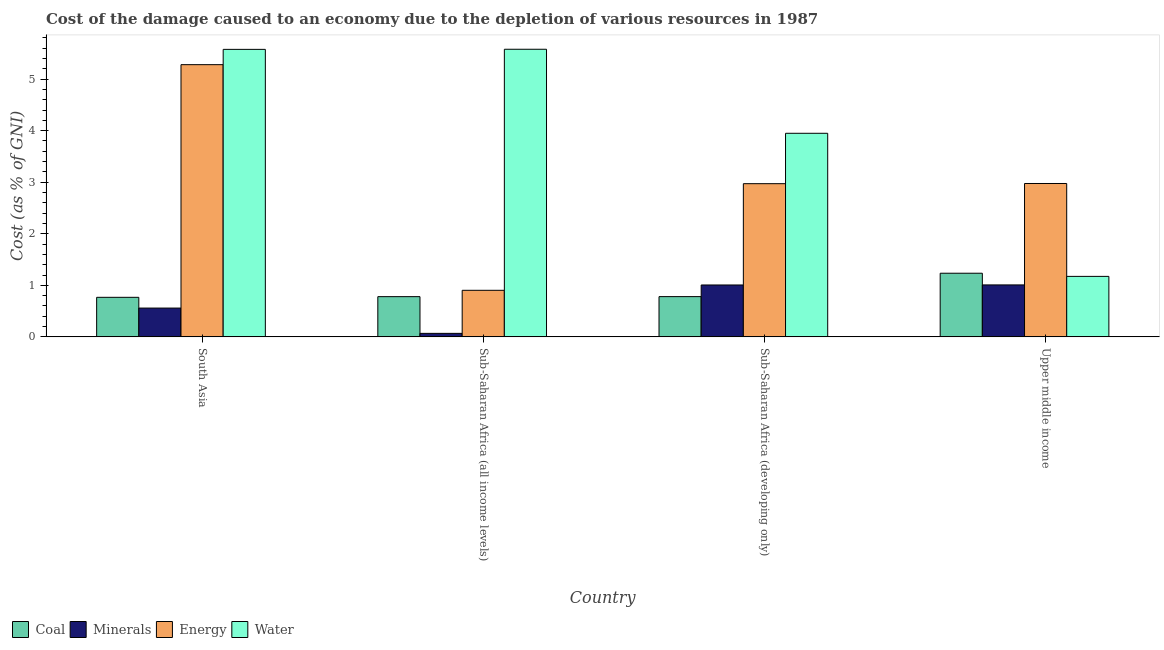How many different coloured bars are there?
Ensure brevity in your answer.  4. How many groups of bars are there?
Make the answer very short. 4. Are the number of bars on each tick of the X-axis equal?
Your answer should be very brief. Yes. What is the label of the 2nd group of bars from the left?
Provide a succinct answer. Sub-Saharan Africa (all income levels). What is the cost of damage due to depletion of minerals in Sub-Saharan Africa (developing only)?
Your response must be concise. 1.01. Across all countries, what is the maximum cost of damage due to depletion of coal?
Provide a short and direct response. 1.23. Across all countries, what is the minimum cost of damage due to depletion of energy?
Keep it short and to the point. 0.9. In which country was the cost of damage due to depletion of coal maximum?
Offer a very short reply. Upper middle income. In which country was the cost of damage due to depletion of minerals minimum?
Offer a very short reply. Sub-Saharan Africa (all income levels). What is the total cost of damage due to depletion of water in the graph?
Make the answer very short. 16.28. What is the difference between the cost of damage due to depletion of water in Sub-Saharan Africa (all income levels) and that in Upper middle income?
Your answer should be compact. 4.41. What is the difference between the cost of damage due to depletion of coal in Sub-Saharan Africa (all income levels) and the cost of damage due to depletion of energy in Sub-Saharan Africa (developing only)?
Ensure brevity in your answer.  -2.19. What is the average cost of damage due to depletion of minerals per country?
Provide a succinct answer. 0.66. What is the difference between the cost of damage due to depletion of minerals and cost of damage due to depletion of water in Sub-Saharan Africa (all income levels)?
Your response must be concise. -5.51. In how many countries, is the cost of damage due to depletion of minerals greater than 1 %?
Your answer should be compact. 2. What is the ratio of the cost of damage due to depletion of energy in South Asia to that in Upper middle income?
Ensure brevity in your answer.  1.77. Is the cost of damage due to depletion of energy in South Asia less than that in Sub-Saharan Africa (all income levels)?
Provide a short and direct response. No. Is the difference between the cost of damage due to depletion of minerals in Sub-Saharan Africa (developing only) and Upper middle income greater than the difference between the cost of damage due to depletion of energy in Sub-Saharan Africa (developing only) and Upper middle income?
Your answer should be very brief. Yes. What is the difference between the highest and the second highest cost of damage due to depletion of energy?
Ensure brevity in your answer.  2.31. What is the difference between the highest and the lowest cost of damage due to depletion of energy?
Give a very brief answer. 4.38. What does the 2nd bar from the left in Sub-Saharan Africa (developing only) represents?
Your answer should be compact. Minerals. What does the 4th bar from the right in Upper middle income represents?
Your answer should be compact. Coal. How many bars are there?
Keep it short and to the point. 16. How many countries are there in the graph?
Give a very brief answer. 4. What is the difference between two consecutive major ticks on the Y-axis?
Provide a short and direct response. 1. Are the values on the major ticks of Y-axis written in scientific E-notation?
Provide a short and direct response. No. Where does the legend appear in the graph?
Your response must be concise. Bottom left. How are the legend labels stacked?
Give a very brief answer. Horizontal. What is the title of the graph?
Provide a short and direct response. Cost of the damage caused to an economy due to the depletion of various resources in 1987 . Does "Permanent crop land" appear as one of the legend labels in the graph?
Provide a succinct answer. No. What is the label or title of the Y-axis?
Provide a succinct answer. Cost (as % of GNI). What is the Cost (as % of GNI) of Coal in South Asia?
Ensure brevity in your answer.  0.77. What is the Cost (as % of GNI) in Minerals in South Asia?
Give a very brief answer. 0.56. What is the Cost (as % of GNI) of Energy in South Asia?
Ensure brevity in your answer.  5.28. What is the Cost (as % of GNI) in Water in South Asia?
Provide a succinct answer. 5.58. What is the Cost (as % of GNI) in Coal in Sub-Saharan Africa (all income levels)?
Your answer should be compact. 0.78. What is the Cost (as % of GNI) of Minerals in Sub-Saharan Africa (all income levels)?
Your answer should be compact. 0.07. What is the Cost (as % of GNI) of Energy in Sub-Saharan Africa (all income levels)?
Your answer should be compact. 0.9. What is the Cost (as % of GNI) of Water in Sub-Saharan Africa (all income levels)?
Make the answer very short. 5.58. What is the Cost (as % of GNI) of Coal in Sub-Saharan Africa (developing only)?
Ensure brevity in your answer.  0.78. What is the Cost (as % of GNI) of Minerals in Sub-Saharan Africa (developing only)?
Provide a succinct answer. 1.01. What is the Cost (as % of GNI) of Energy in Sub-Saharan Africa (developing only)?
Provide a succinct answer. 2.97. What is the Cost (as % of GNI) in Water in Sub-Saharan Africa (developing only)?
Your answer should be very brief. 3.95. What is the Cost (as % of GNI) in Coal in Upper middle income?
Keep it short and to the point. 1.23. What is the Cost (as % of GNI) of Minerals in Upper middle income?
Provide a succinct answer. 1.01. What is the Cost (as % of GNI) in Energy in Upper middle income?
Your response must be concise. 2.98. What is the Cost (as % of GNI) of Water in Upper middle income?
Ensure brevity in your answer.  1.17. Across all countries, what is the maximum Cost (as % of GNI) in Coal?
Keep it short and to the point. 1.23. Across all countries, what is the maximum Cost (as % of GNI) in Minerals?
Give a very brief answer. 1.01. Across all countries, what is the maximum Cost (as % of GNI) of Energy?
Make the answer very short. 5.28. Across all countries, what is the maximum Cost (as % of GNI) of Water?
Make the answer very short. 5.58. Across all countries, what is the minimum Cost (as % of GNI) of Coal?
Provide a succinct answer. 0.77. Across all countries, what is the minimum Cost (as % of GNI) of Minerals?
Your answer should be very brief. 0.07. Across all countries, what is the minimum Cost (as % of GNI) of Energy?
Your answer should be very brief. 0.9. Across all countries, what is the minimum Cost (as % of GNI) of Water?
Keep it short and to the point. 1.17. What is the total Cost (as % of GNI) of Coal in the graph?
Offer a very short reply. 3.56. What is the total Cost (as % of GNI) of Minerals in the graph?
Ensure brevity in your answer.  2.64. What is the total Cost (as % of GNI) of Energy in the graph?
Offer a very short reply. 12.13. What is the total Cost (as % of GNI) in Water in the graph?
Ensure brevity in your answer.  16.28. What is the difference between the Cost (as % of GNI) of Coal in South Asia and that in Sub-Saharan Africa (all income levels)?
Ensure brevity in your answer.  -0.01. What is the difference between the Cost (as % of GNI) in Minerals in South Asia and that in Sub-Saharan Africa (all income levels)?
Provide a short and direct response. 0.49. What is the difference between the Cost (as % of GNI) in Energy in South Asia and that in Sub-Saharan Africa (all income levels)?
Your response must be concise. 4.38. What is the difference between the Cost (as % of GNI) in Water in South Asia and that in Sub-Saharan Africa (all income levels)?
Offer a terse response. -0. What is the difference between the Cost (as % of GNI) in Coal in South Asia and that in Sub-Saharan Africa (developing only)?
Offer a terse response. -0.01. What is the difference between the Cost (as % of GNI) of Minerals in South Asia and that in Sub-Saharan Africa (developing only)?
Ensure brevity in your answer.  -0.45. What is the difference between the Cost (as % of GNI) of Energy in South Asia and that in Sub-Saharan Africa (developing only)?
Make the answer very short. 2.31. What is the difference between the Cost (as % of GNI) in Water in South Asia and that in Sub-Saharan Africa (developing only)?
Provide a short and direct response. 1.63. What is the difference between the Cost (as % of GNI) of Coal in South Asia and that in Upper middle income?
Offer a terse response. -0.47. What is the difference between the Cost (as % of GNI) of Minerals in South Asia and that in Upper middle income?
Make the answer very short. -0.45. What is the difference between the Cost (as % of GNI) of Energy in South Asia and that in Upper middle income?
Offer a terse response. 2.31. What is the difference between the Cost (as % of GNI) of Water in South Asia and that in Upper middle income?
Ensure brevity in your answer.  4.4. What is the difference between the Cost (as % of GNI) of Coal in Sub-Saharan Africa (all income levels) and that in Sub-Saharan Africa (developing only)?
Provide a succinct answer. -0. What is the difference between the Cost (as % of GNI) of Minerals in Sub-Saharan Africa (all income levels) and that in Sub-Saharan Africa (developing only)?
Make the answer very short. -0.94. What is the difference between the Cost (as % of GNI) of Energy in Sub-Saharan Africa (all income levels) and that in Sub-Saharan Africa (developing only)?
Provide a short and direct response. -2.07. What is the difference between the Cost (as % of GNI) of Water in Sub-Saharan Africa (all income levels) and that in Sub-Saharan Africa (developing only)?
Your response must be concise. 1.63. What is the difference between the Cost (as % of GNI) in Coal in Sub-Saharan Africa (all income levels) and that in Upper middle income?
Offer a very short reply. -0.45. What is the difference between the Cost (as % of GNI) in Minerals in Sub-Saharan Africa (all income levels) and that in Upper middle income?
Provide a succinct answer. -0.94. What is the difference between the Cost (as % of GNI) of Energy in Sub-Saharan Africa (all income levels) and that in Upper middle income?
Provide a succinct answer. -2.07. What is the difference between the Cost (as % of GNI) in Water in Sub-Saharan Africa (all income levels) and that in Upper middle income?
Offer a very short reply. 4.41. What is the difference between the Cost (as % of GNI) in Coal in Sub-Saharan Africa (developing only) and that in Upper middle income?
Give a very brief answer. -0.45. What is the difference between the Cost (as % of GNI) in Minerals in Sub-Saharan Africa (developing only) and that in Upper middle income?
Provide a short and direct response. -0. What is the difference between the Cost (as % of GNI) of Energy in Sub-Saharan Africa (developing only) and that in Upper middle income?
Keep it short and to the point. -0. What is the difference between the Cost (as % of GNI) in Water in Sub-Saharan Africa (developing only) and that in Upper middle income?
Offer a very short reply. 2.78. What is the difference between the Cost (as % of GNI) of Coal in South Asia and the Cost (as % of GNI) of Minerals in Sub-Saharan Africa (all income levels)?
Provide a short and direct response. 0.7. What is the difference between the Cost (as % of GNI) of Coal in South Asia and the Cost (as % of GNI) of Energy in Sub-Saharan Africa (all income levels)?
Provide a succinct answer. -0.14. What is the difference between the Cost (as % of GNI) of Coal in South Asia and the Cost (as % of GNI) of Water in Sub-Saharan Africa (all income levels)?
Ensure brevity in your answer.  -4.81. What is the difference between the Cost (as % of GNI) in Minerals in South Asia and the Cost (as % of GNI) in Energy in Sub-Saharan Africa (all income levels)?
Offer a very short reply. -0.34. What is the difference between the Cost (as % of GNI) in Minerals in South Asia and the Cost (as % of GNI) in Water in Sub-Saharan Africa (all income levels)?
Provide a short and direct response. -5.02. What is the difference between the Cost (as % of GNI) in Energy in South Asia and the Cost (as % of GNI) in Water in Sub-Saharan Africa (all income levels)?
Ensure brevity in your answer.  -0.3. What is the difference between the Cost (as % of GNI) of Coal in South Asia and the Cost (as % of GNI) of Minerals in Sub-Saharan Africa (developing only)?
Give a very brief answer. -0.24. What is the difference between the Cost (as % of GNI) in Coal in South Asia and the Cost (as % of GNI) in Energy in Sub-Saharan Africa (developing only)?
Make the answer very short. -2.2. What is the difference between the Cost (as % of GNI) of Coal in South Asia and the Cost (as % of GNI) of Water in Sub-Saharan Africa (developing only)?
Offer a very short reply. -3.18. What is the difference between the Cost (as % of GNI) of Minerals in South Asia and the Cost (as % of GNI) of Energy in Sub-Saharan Africa (developing only)?
Provide a short and direct response. -2.41. What is the difference between the Cost (as % of GNI) in Minerals in South Asia and the Cost (as % of GNI) in Water in Sub-Saharan Africa (developing only)?
Your answer should be compact. -3.39. What is the difference between the Cost (as % of GNI) in Energy in South Asia and the Cost (as % of GNI) in Water in Sub-Saharan Africa (developing only)?
Provide a short and direct response. 1.33. What is the difference between the Cost (as % of GNI) in Coal in South Asia and the Cost (as % of GNI) in Minerals in Upper middle income?
Keep it short and to the point. -0.24. What is the difference between the Cost (as % of GNI) of Coal in South Asia and the Cost (as % of GNI) of Energy in Upper middle income?
Offer a very short reply. -2.21. What is the difference between the Cost (as % of GNI) of Coal in South Asia and the Cost (as % of GNI) of Water in Upper middle income?
Make the answer very short. -0.41. What is the difference between the Cost (as % of GNI) in Minerals in South Asia and the Cost (as % of GNI) in Energy in Upper middle income?
Your response must be concise. -2.42. What is the difference between the Cost (as % of GNI) of Minerals in South Asia and the Cost (as % of GNI) of Water in Upper middle income?
Provide a succinct answer. -0.61. What is the difference between the Cost (as % of GNI) in Energy in South Asia and the Cost (as % of GNI) in Water in Upper middle income?
Keep it short and to the point. 4.11. What is the difference between the Cost (as % of GNI) of Coal in Sub-Saharan Africa (all income levels) and the Cost (as % of GNI) of Minerals in Sub-Saharan Africa (developing only)?
Your response must be concise. -0.23. What is the difference between the Cost (as % of GNI) in Coal in Sub-Saharan Africa (all income levels) and the Cost (as % of GNI) in Energy in Sub-Saharan Africa (developing only)?
Provide a short and direct response. -2.19. What is the difference between the Cost (as % of GNI) of Coal in Sub-Saharan Africa (all income levels) and the Cost (as % of GNI) of Water in Sub-Saharan Africa (developing only)?
Provide a short and direct response. -3.17. What is the difference between the Cost (as % of GNI) in Minerals in Sub-Saharan Africa (all income levels) and the Cost (as % of GNI) in Energy in Sub-Saharan Africa (developing only)?
Ensure brevity in your answer.  -2.9. What is the difference between the Cost (as % of GNI) of Minerals in Sub-Saharan Africa (all income levels) and the Cost (as % of GNI) of Water in Sub-Saharan Africa (developing only)?
Ensure brevity in your answer.  -3.88. What is the difference between the Cost (as % of GNI) in Energy in Sub-Saharan Africa (all income levels) and the Cost (as % of GNI) in Water in Sub-Saharan Africa (developing only)?
Ensure brevity in your answer.  -3.05. What is the difference between the Cost (as % of GNI) in Coal in Sub-Saharan Africa (all income levels) and the Cost (as % of GNI) in Minerals in Upper middle income?
Offer a terse response. -0.23. What is the difference between the Cost (as % of GNI) of Coal in Sub-Saharan Africa (all income levels) and the Cost (as % of GNI) of Energy in Upper middle income?
Ensure brevity in your answer.  -2.19. What is the difference between the Cost (as % of GNI) in Coal in Sub-Saharan Africa (all income levels) and the Cost (as % of GNI) in Water in Upper middle income?
Your answer should be compact. -0.39. What is the difference between the Cost (as % of GNI) in Minerals in Sub-Saharan Africa (all income levels) and the Cost (as % of GNI) in Energy in Upper middle income?
Provide a succinct answer. -2.91. What is the difference between the Cost (as % of GNI) in Minerals in Sub-Saharan Africa (all income levels) and the Cost (as % of GNI) in Water in Upper middle income?
Offer a very short reply. -1.11. What is the difference between the Cost (as % of GNI) in Energy in Sub-Saharan Africa (all income levels) and the Cost (as % of GNI) in Water in Upper middle income?
Your answer should be compact. -0.27. What is the difference between the Cost (as % of GNI) in Coal in Sub-Saharan Africa (developing only) and the Cost (as % of GNI) in Minerals in Upper middle income?
Provide a short and direct response. -0.23. What is the difference between the Cost (as % of GNI) of Coal in Sub-Saharan Africa (developing only) and the Cost (as % of GNI) of Energy in Upper middle income?
Make the answer very short. -2.19. What is the difference between the Cost (as % of GNI) of Coal in Sub-Saharan Africa (developing only) and the Cost (as % of GNI) of Water in Upper middle income?
Offer a terse response. -0.39. What is the difference between the Cost (as % of GNI) of Minerals in Sub-Saharan Africa (developing only) and the Cost (as % of GNI) of Energy in Upper middle income?
Give a very brief answer. -1.97. What is the difference between the Cost (as % of GNI) in Minerals in Sub-Saharan Africa (developing only) and the Cost (as % of GNI) in Water in Upper middle income?
Your response must be concise. -0.17. What is the difference between the Cost (as % of GNI) in Energy in Sub-Saharan Africa (developing only) and the Cost (as % of GNI) in Water in Upper middle income?
Ensure brevity in your answer.  1.8. What is the average Cost (as % of GNI) in Coal per country?
Give a very brief answer. 0.89. What is the average Cost (as % of GNI) of Minerals per country?
Offer a very short reply. 0.66. What is the average Cost (as % of GNI) in Energy per country?
Your answer should be very brief. 3.03. What is the average Cost (as % of GNI) in Water per country?
Offer a terse response. 4.07. What is the difference between the Cost (as % of GNI) of Coal and Cost (as % of GNI) of Minerals in South Asia?
Provide a short and direct response. 0.21. What is the difference between the Cost (as % of GNI) of Coal and Cost (as % of GNI) of Energy in South Asia?
Offer a terse response. -4.51. What is the difference between the Cost (as % of GNI) of Coal and Cost (as % of GNI) of Water in South Asia?
Your answer should be very brief. -4.81. What is the difference between the Cost (as % of GNI) in Minerals and Cost (as % of GNI) in Energy in South Asia?
Your response must be concise. -4.72. What is the difference between the Cost (as % of GNI) in Minerals and Cost (as % of GNI) in Water in South Asia?
Offer a very short reply. -5.02. What is the difference between the Cost (as % of GNI) in Energy and Cost (as % of GNI) in Water in South Asia?
Provide a succinct answer. -0.3. What is the difference between the Cost (as % of GNI) in Coal and Cost (as % of GNI) in Minerals in Sub-Saharan Africa (all income levels)?
Give a very brief answer. 0.71. What is the difference between the Cost (as % of GNI) of Coal and Cost (as % of GNI) of Energy in Sub-Saharan Africa (all income levels)?
Your answer should be compact. -0.12. What is the difference between the Cost (as % of GNI) in Coal and Cost (as % of GNI) in Water in Sub-Saharan Africa (all income levels)?
Your answer should be very brief. -4.8. What is the difference between the Cost (as % of GNI) in Minerals and Cost (as % of GNI) in Energy in Sub-Saharan Africa (all income levels)?
Provide a succinct answer. -0.84. What is the difference between the Cost (as % of GNI) in Minerals and Cost (as % of GNI) in Water in Sub-Saharan Africa (all income levels)?
Keep it short and to the point. -5.51. What is the difference between the Cost (as % of GNI) in Energy and Cost (as % of GNI) in Water in Sub-Saharan Africa (all income levels)?
Offer a terse response. -4.68. What is the difference between the Cost (as % of GNI) in Coal and Cost (as % of GNI) in Minerals in Sub-Saharan Africa (developing only)?
Your answer should be very brief. -0.23. What is the difference between the Cost (as % of GNI) in Coal and Cost (as % of GNI) in Energy in Sub-Saharan Africa (developing only)?
Your answer should be compact. -2.19. What is the difference between the Cost (as % of GNI) of Coal and Cost (as % of GNI) of Water in Sub-Saharan Africa (developing only)?
Provide a short and direct response. -3.17. What is the difference between the Cost (as % of GNI) of Minerals and Cost (as % of GNI) of Energy in Sub-Saharan Africa (developing only)?
Offer a very short reply. -1.97. What is the difference between the Cost (as % of GNI) in Minerals and Cost (as % of GNI) in Water in Sub-Saharan Africa (developing only)?
Your response must be concise. -2.94. What is the difference between the Cost (as % of GNI) in Energy and Cost (as % of GNI) in Water in Sub-Saharan Africa (developing only)?
Offer a terse response. -0.98. What is the difference between the Cost (as % of GNI) in Coal and Cost (as % of GNI) in Minerals in Upper middle income?
Ensure brevity in your answer.  0.23. What is the difference between the Cost (as % of GNI) in Coal and Cost (as % of GNI) in Energy in Upper middle income?
Provide a succinct answer. -1.74. What is the difference between the Cost (as % of GNI) in Coal and Cost (as % of GNI) in Water in Upper middle income?
Your answer should be very brief. 0.06. What is the difference between the Cost (as % of GNI) in Minerals and Cost (as % of GNI) in Energy in Upper middle income?
Offer a very short reply. -1.97. What is the difference between the Cost (as % of GNI) in Minerals and Cost (as % of GNI) in Water in Upper middle income?
Your answer should be compact. -0.17. What is the difference between the Cost (as % of GNI) in Energy and Cost (as % of GNI) in Water in Upper middle income?
Give a very brief answer. 1.8. What is the ratio of the Cost (as % of GNI) in Coal in South Asia to that in Sub-Saharan Africa (all income levels)?
Offer a very short reply. 0.98. What is the ratio of the Cost (as % of GNI) in Minerals in South Asia to that in Sub-Saharan Africa (all income levels)?
Make the answer very short. 8.22. What is the ratio of the Cost (as % of GNI) in Energy in South Asia to that in Sub-Saharan Africa (all income levels)?
Make the answer very short. 5.85. What is the ratio of the Cost (as % of GNI) of Coal in South Asia to that in Sub-Saharan Africa (developing only)?
Offer a terse response. 0.98. What is the ratio of the Cost (as % of GNI) of Minerals in South Asia to that in Sub-Saharan Africa (developing only)?
Give a very brief answer. 0.56. What is the ratio of the Cost (as % of GNI) of Energy in South Asia to that in Sub-Saharan Africa (developing only)?
Make the answer very short. 1.78. What is the ratio of the Cost (as % of GNI) in Water in South Asia to that in Sub-Saharan Africa (developing only)?
Your answer should be compact. 1.41. What is the ratio of the Cost (as % of GNI) of Coal in South Asia to that in Upper middle income?
Offer a very short reply. 0.62. What is the ratio of the Cost (as % of GNI) of Minerals in South Asia to that in Upper middle income?
Give a very brief answer. 0.55. What is the ratio of the Cost (as % of GNI) of Energy in South Asia to that in Upper middle income?
Offer a very short reply. 1.77. What is the ratio of the Cost (as % of GNI) in Water in South Asia to that in Upper middle income?
Ensure brevity in your answer.  4.75. What is the ratio of the Cost (as % of GNI) in Minerals in Sub-Saharan Africa (all income levels) to that in Sub-Saharan Africa (developing only)?
Your response must be concise. 0.07. What is the ratio of the Cost (as % of GNI) in Energy in Sub-Saharan Africa (all income levels) to that in Sub-Saharan Africa (developing only)?
Provide a short and direct response. 0.3. What is the ratio of the Cost (as % of GNI) of Water in Sub-Saharan Africa (all income levels) to that in Sub-Saharan Africa (developing only)?
Offer a very short reply. 1.41. What is the ratio of the Cost (as % of GNI) in Coal in Sub-Saharan Africa (all income levels) to that in Upper middle income?
Your response must be concise. 0.63. What is the ratio of the Cost (as % of GNI) of Minerals in Sub-Saharan Africa (all income levels) to that in Upper middle income?
Keep it short and to the point. 0.07. What is the ratio of the Cost (as % of GNI) of Energy in Sub-Saharan Africa (all income levels) to that in Upper middle income?
Ensure brevity in your answer.  0.3. What is the ratio of the Cost (as % of GNI) of Water in Sub-Saharan Africa (all income levels) to that in Upper middle income?
Provide a succinct answer. 4.75. What is the ratio of the Cost (as % of GNI) of Coal in Sub-Saharan Africa (developing only) to that in Upper middle income?
Your answer should be very brief. 0.63. What is the ratio of the Cost (as % of GNI) of Energy in Sub-Saharan Africa (developing only) to that in Upper middle income?
Give a very brief answer. 1. What is the ratio of the Cost (as % of GNI) of Water in Sub-Saharan Africa (developing only) to that in Upper middle income?
Provide a short and direct response. 3.37. What is the difference between the highest and the second highest Cost (as % of GNI) in Coal?
Provide a succinct answer. 0.45. What is the difference between the highest and the second highest Cost (as % of GNI) of Minerals?
Offer a terse response. 0. What is the difference between the highest and the second highest Cost (as % of GNI) of Energy?
Make the answer very short. 2.31. What is the difference between the highest and the second highest Cost (as % of GNI) of Water?
Your response must be concise. 0. What is the difference between the highest and the lowest Cost (as % of GNI) of Coal?
Your response must be concise. 0.47. What is the difference between the highest and the lowest Cost (as % of GNI) of Minerals?
Your answer should be very brief. 0.94. What is the difference between the highest and the lowest Cost (as % of GNI) of Energy?
Your answer should be very brief. 4.38. What is the difference between the highest and the lowest Cost (as % of GNI) in Water?
Your answer should be compact. 4.41. 